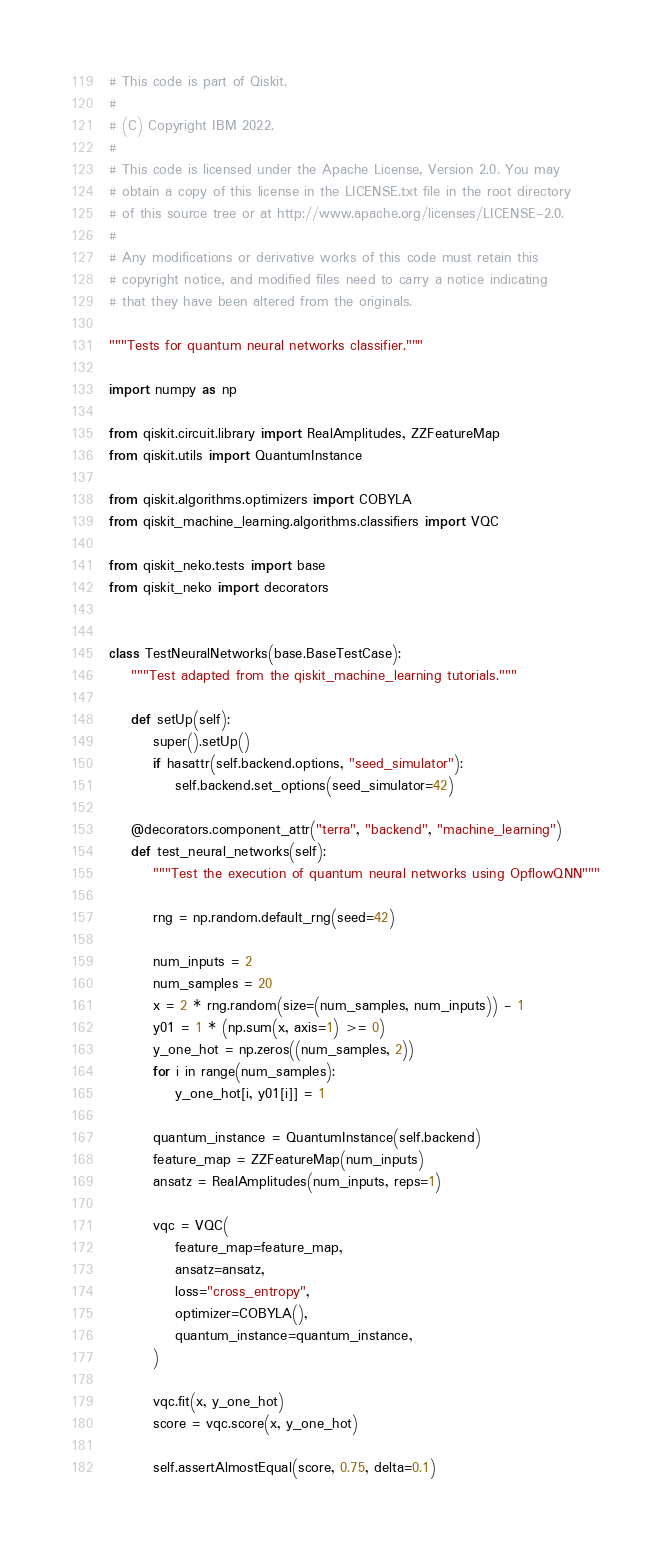<code> <loc_0><loc_0><loc_500><loc_500><_Python_># This code is part of Qiskit.
#
# (C) Copyright IBM 2022.
#
# This code is licensed under the Apache License, Version 2.0. You may
# obtain a copy of this license in the LICENSE.txt file in the root directory
# of this source tree or at http://www.apache.org/licenses/LICENSE-2.0.
#
# Any modifications or derivative works of this code must retain this
# copyright notice, and modified files need to carry a notice indicating
# that they have been altered from the originals.

"""Tests for quantum neural networks classifier."""

import numpy as np

from qiskit.circuit.library import RealAmplitudes, ZZFeatureMap
from qiskit.utils import QuantumInstance

from qiskit.algorithms.optimizers import COBYLA
from qiskit_machine_learning.algorithms.classifiers import VQC

from qiskit_neko.tests import base
from qiskit_neko import decorators


class TestNeuralNetworks(base.BaseTestCase):
    """Test adapted from the qiskit_machine_learning tutorials."""

    def setUp(self):
        super().setUp()
        if hasattr(self.backend.options, "seed_simulator"):
            self.backend.set_options(seed_simulator=42)

    @decorators.component_attr("terra", "backend", "machine_learning")
    def test_neural_networks(self):
        """Test the execution of quantum neural networks using OpflowQNN"""

        rng = np.random.default_rng(seed=42)

        num_inputs = 2
        num_samples = 20
        x = 2 * rng.random(size=(num_samples, num_inputs)) - 1
        y01 = 1 * (np.sum(x, axis=1) >= 0)
        y_one_hot = np.zeros((num_samples, 2))
        for i in range(num_samples):
            y_one_hot[i, y01[i]] = 1

        quantum_instance = QuantumInstance(self.backend)
        feature_map = ZZFeatureMap(num_inputs)
        ansatz = RealAmplitudes(num_inputs, reps=1)

        vqc = VQC(
            feature_map=feature_map,
            ansatz=ansatz,
            loss="cross_entropy",
            optimizer=COBYLA(),
            quantum_instance=quantum_instance,
        )

        vqc.fit(x, y_one_hot)
        score = vqc.score(x, y_one_hot)

        self.assertAlmostEqual(score, 0.75, delta=0.1)
</code> 